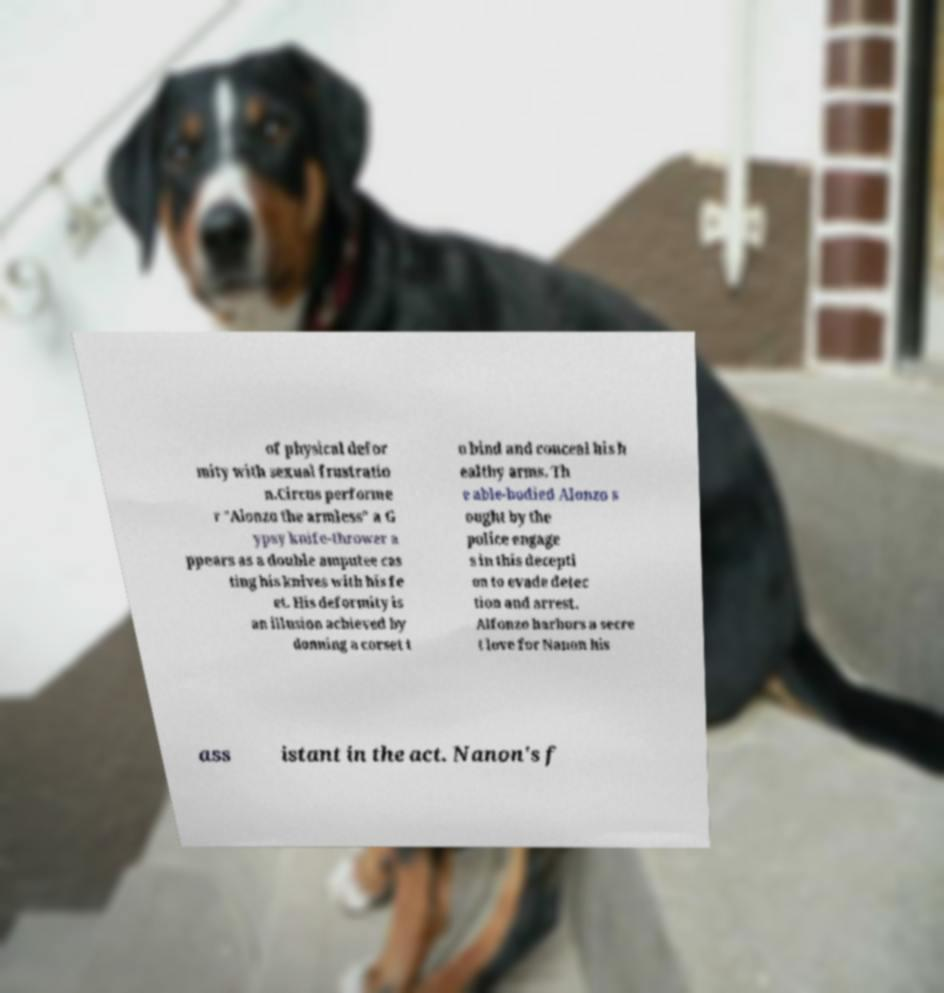Can you read and provide the text displayed in the image?This photo seems to have some interesting text. Can you extract and type it out for me? of physical defor mity with sexual frustratio n.Circus performe r "Alonzo the armless" a G ypsy knife-thrower a ppears as a double amputee cas ting his knives with his fe et. His deformity is an illusion achieved by donning a corset t o bind and conceal his h ealthy arms. Th e able-bodied Alonzo s ought by the police engage s in this decepti on to evade detec tion and arrest. Alfonzo harbors a secre t love for Nanon his ass istant in the act. Nanon's f 